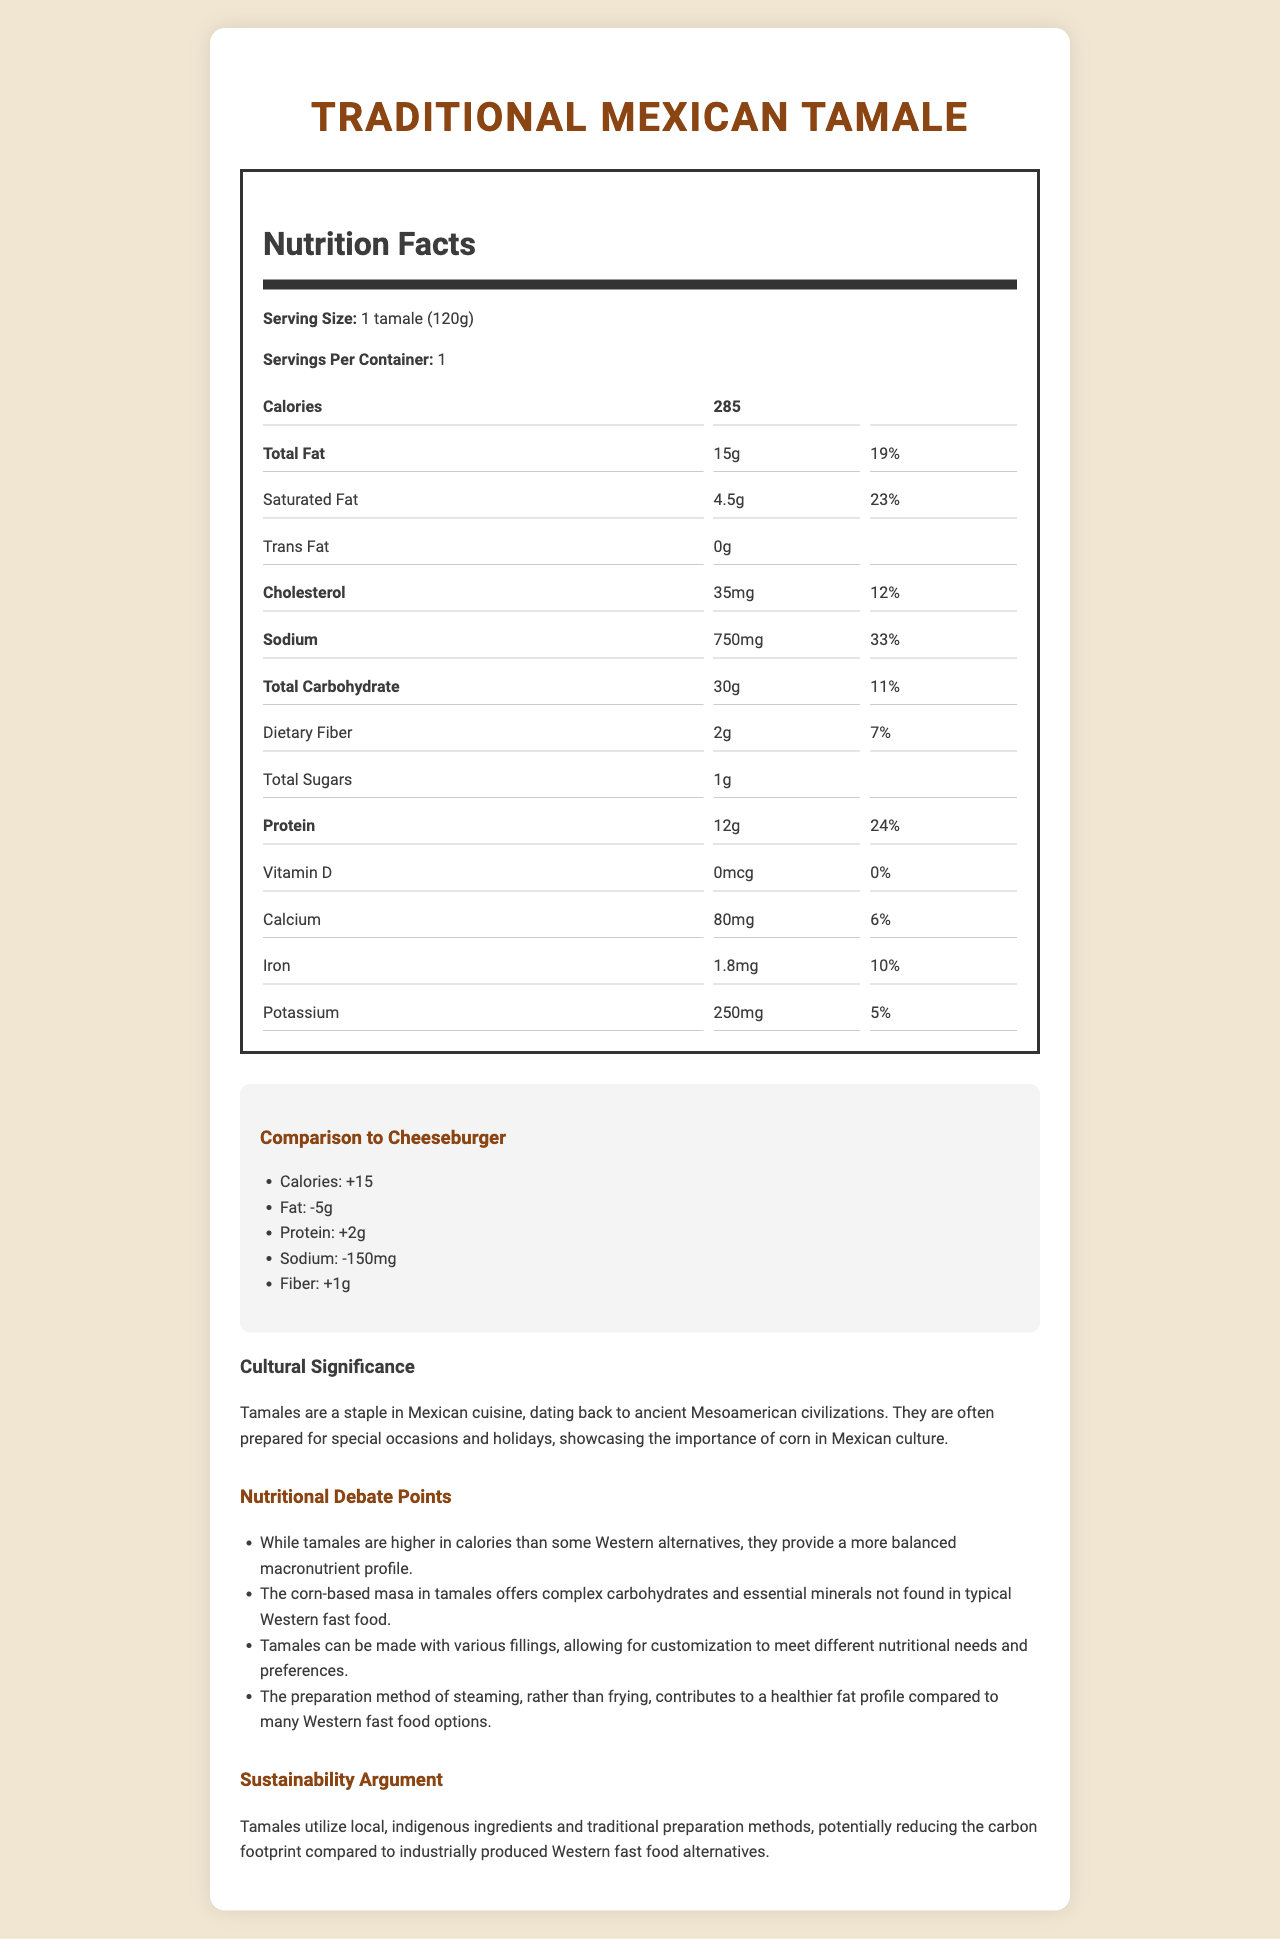what is the serving size of the Traditional Mexican Tamale? The serving size is mentioned in the nutrition label under "Serving Size".
Answer: 1 tamale (120g) how much calcium is in one serving of the Traditional Mexican Tamale? The amount of calcium is listed under the nutrition facts in the nutrition label.
Answer: 80 mg what percentage of the daily value of saturated fat do you get from one tamale? The daily value percentage for saturated fat is provided in the nutrition label.
Answer: 23% What cultural significance do tamales hold in Mexican cuisine? The document mentions the cultural significance in the "Cultural Significance" section.
Answer: They are a staple in Mexican cuisine, dating back to ancient Mesoamerican civilizations, and are often prepared for special occasions and holidays. how many grams of protein are in one tamale? The amount of protein per serving is listed in the nutrition facts section.
Answer: 12g compared to a cheeseburger, how many more or fewer grams of fat does a tamale have? The comparison section states that a tamale has 5 grams less fat compared to a cheeseburger.
Answer: 5 grams fewer how does the sodium content of a tamale compare to a cheeseburger? The comparison to Western alternative section specifies that the tamale has 150 mg less sodium.
Answer: 150 mg lower Which of the following nutrients has the highest daily value percentage in a tamale? A. Total Fat B. Saturated Fat C. Sodium D. Protein According to the nutrition facts, total fat has a daily value of 19%, which is the highest among the options.
Answer: A. Total Fat Based on the debatements, what is a potential nutritional benefit of tamales over Western fast food? One of the nutritional debate points states that tamales offer a balanced macronutrient profile.
Answer: Tamales provide a more balanced macronutrient profile. Are tamales steamed or fried? The preparation method is mentioned in the nutritional debate points section which explains the steaming method contributing to a healthier fat profile.
Answer: Steamed Which component is not present in the nutritional composition of the tamale? A. Trans Fat B. Vitamin D C. Cholesterol D. Sugars The nutrition facts section shows that trans fat amount is listed as 0g.
Answer: A. Trans Fat Summarize the key nutritional and cultural information about the Traditional Mexican Tamale. The summary incorporates the nutritional values, cultural significance, and comparison to Western alternatives covered in the document.
Answer: The Traditional Mexican Tamale serves as a staple in Mexican cuisine with cultural significance, made from local ingredients. Nutritionally, it has 285 calories, 15g of total fat, 12g of protein, and various vitamins and minerals, compared to Western options like cheeseburgers it has a better nutritional profile in many areas. What vitamin is not present in the tamale? The nutrition facts section indicates that the amount of vitamin D is 0 mcg.
Answer: Vitamin D How much dietary fiber does a tamale contain? The amount of dietary fiber is listed in the nutrition facts section under dietary fiber.
Answer: 2g Is the carbon footprint of tamales potentially lower than Western fast food? The sustainability argument mentions that tamales potentially reduce the carbon footprint due to their local, indigenous ingredients and traditional preparation methods.
Answer: Yes What is the difference in protein content between a tamale and a cheeseburger? The comparison section indicates that a tamale has 2 grams more protein than a cheeseburger.
Answer: 2g more What is the historical significance of tamales in Mexican culture? The document gives information about tamales being a staple dating back to ancient civilizations but does not detail the historical significance beyond this.
Answer: It is not detailed in the document. 